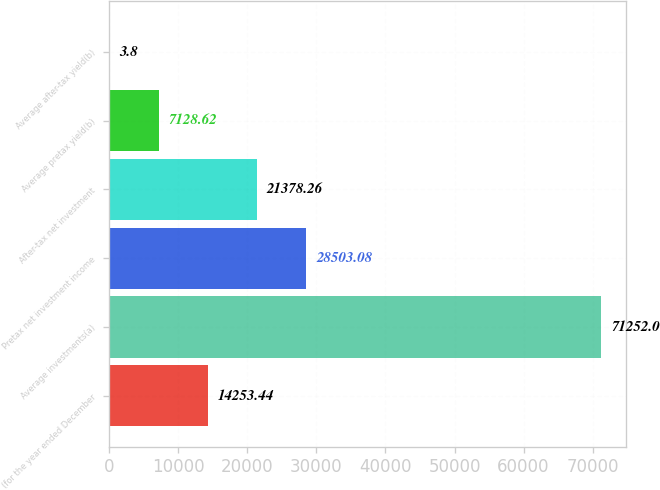Convert chart to OTSL. <chart><loc_0><loc_0><loc_500><loc_500><bar_chart><fcel>(for the year ended December<fcel>Average investments(a)<fcel>Pretax net investment income<fcel>After-tax net investment<fcel>Average pretax yield(b)<fcel>Average after-tax yield(b)<nl><fcel>14253.4<fcel>71252<fcel>28503.1<fcel>21378.3<fcel>7128.62<fcel>3.8<nl></chart> 